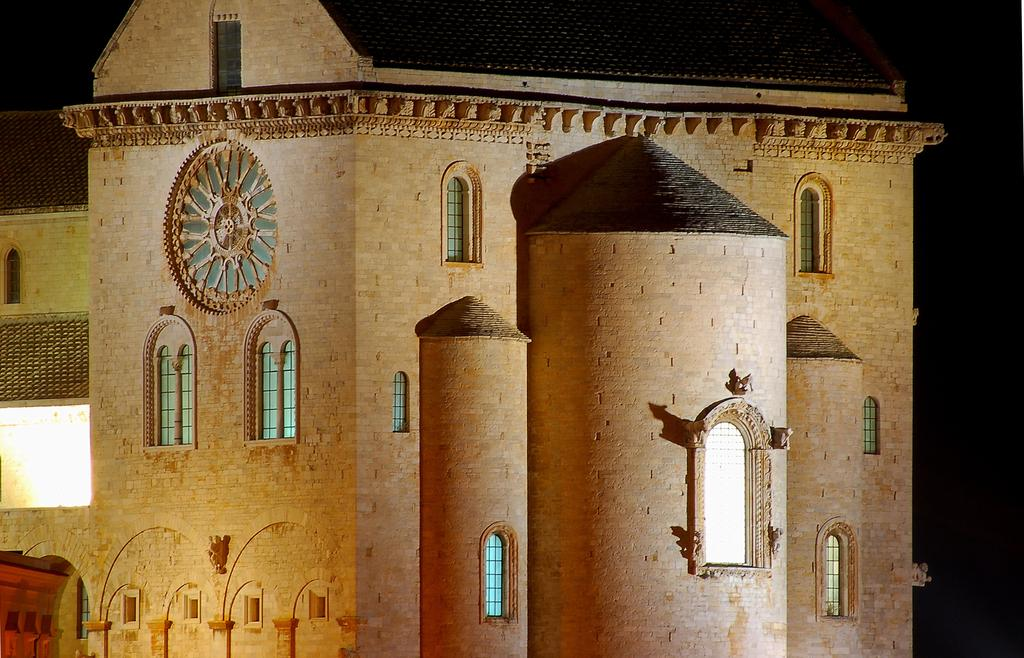What is the main subject of the picture? The main subject of the picture is a building. What specific features can be observed on the building? The building has windows. What type of metal is used to create the fear in the building's inhabitants? There is no mention of fear or metal in the image, and therefore no such connection can be made. 